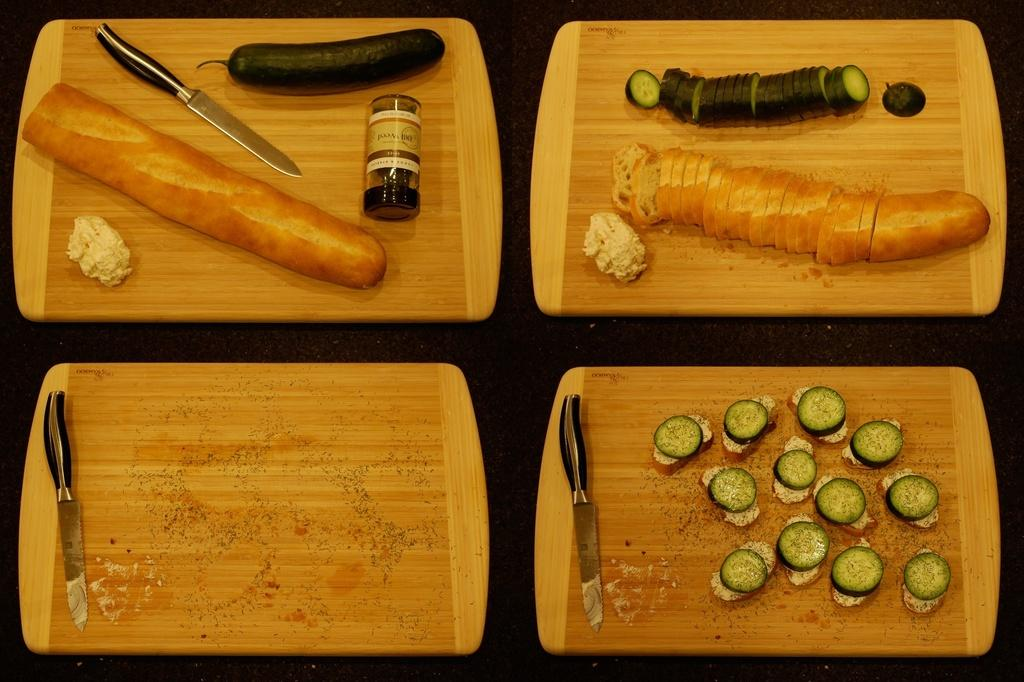What is located in the middle of the image? There are four choppers in the middle of the image. What can be seen on the choppers? Pieces of carrot and another vegetable are visible on the choppers. What utensils are present in the image? Knives are present in the image. What else can be seen in the image besides the choppers and knives? A bottle is visible in the image. How are the vegetables being prepared? Pieces of vegetables are visible on the choppers, indicating that they are being chopped. What type of hat is the carrot wearing in the image? There are no hats present in the image, and carrots do not wear hats. How many thumbs are visible in the image? There are no thumbs visible in the image, as the image only shows vegetables and utensils. 